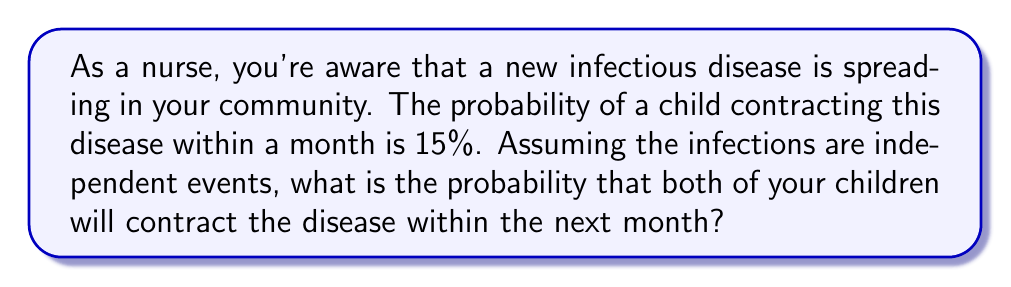Provide a solution to this math problem. Let's approach this step-by-step:

1) Let's define our events:
   A: First child contracts the disease
   B: Second child contracts the disease

2) We're given that P(A) = P(B) = 0.15 (15% expressed as a decimal)

3) We need to find P(A and B), the probability of both events occurring

4) Since the infections are independent events, we can use the multiplication rule of probability:

   $$P(A \text{ and } B) = P(A) \times P(B)$$

5) Substituting our known probabilities:

   $$P(A \text{ and } B) = 0.15 \times 0.15$$

6) Calculating:

   $$P(A \text{ and } B) = 0.0225$$

7) Converting to a percentage:

   $$0.0225 \times 100\% = 2.25\%$$

Therefore, the probability that both children will contract the disease within the next month is 2.25%.
Answer: 2.25% 